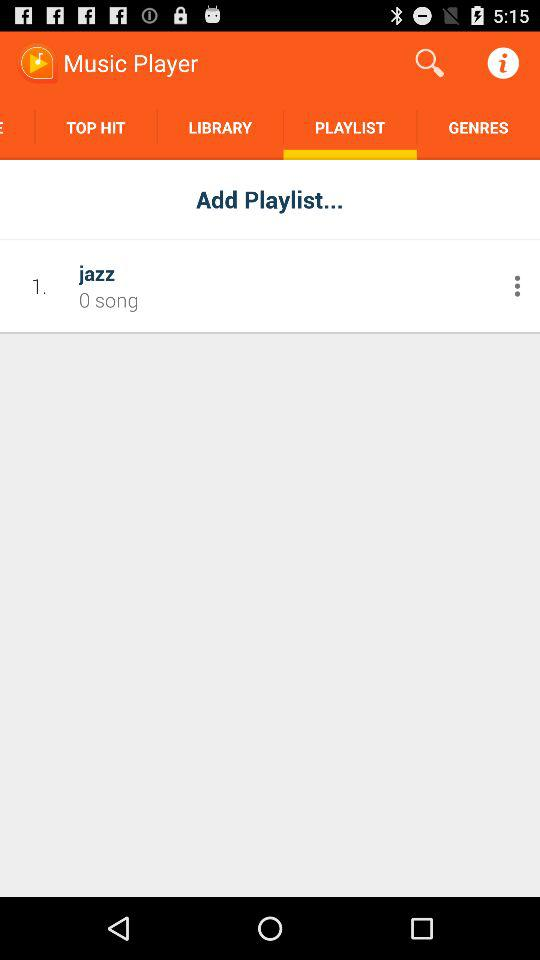How many songs are present in the "jazz" playlist? There are 0 songs present in the "jazz" playlist. 